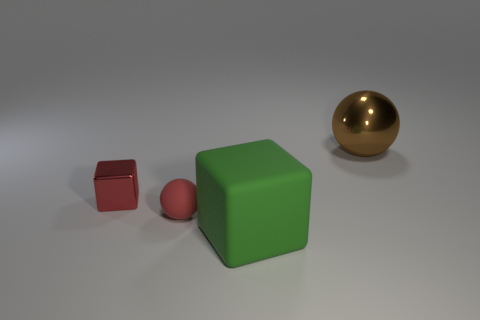What is the material of the small sphere that is the same color as the small shiny thing?
Offer a terse response. Rubber. There is a sphere that is in front of the brown sphere; is it the same color as the tiny cube?
Offer a terse response. Yes. There is a metallic thing on the left side of the large ball; is it the same shape as the small red matte object?
Your answer should be compact. No. There is a cube in front of the tiny red object that is on the left side of the tiny red rubber ball; what color is it?
Give a very brief answer. Green. Are there fewer red rubber spheres than large blue metal cubes?
Your answer should be compact. No. Are there any red things that have the same material as the red sphere?
Make the answer very short. No. Does the big shiny object have the same shape as the matte thing behind the green matte object?
Make the answer very short. Yes. Are there any big blocks behind the green block?
Offer a terse response. No. What number of shiny objects are the same shape as the large green matte object?
Offer a terse response. 1. Do the tiny ball and the large thing that is behind the metallic block have the same material?
Make the answer very short. No. 